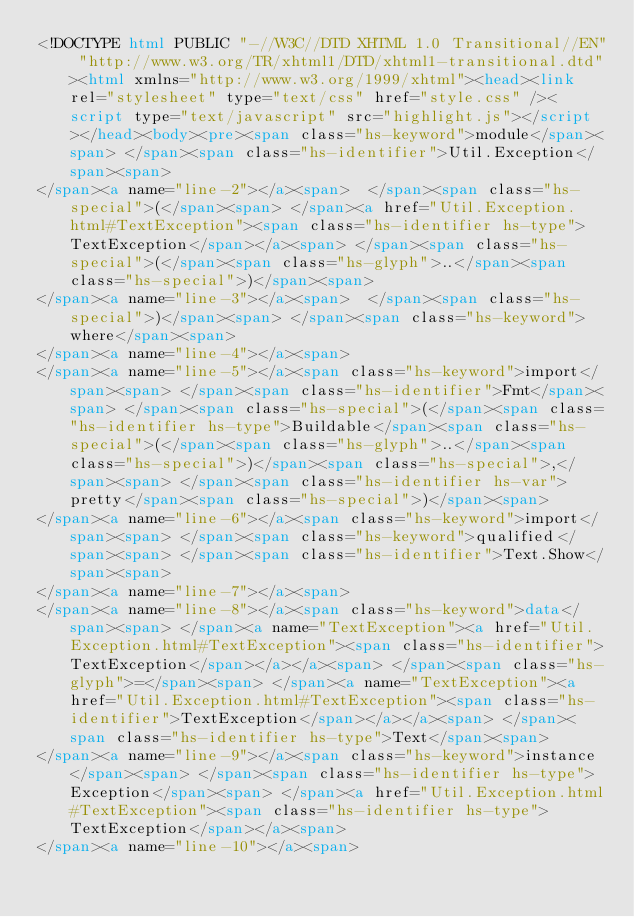<code> <loc_0><loc_0><loc_500><loc_500><_HTML_><!DOCTYPE html PUBLIC "-//W3C//DTD XHTML 1.0 Transitional//EN" "http://www.w3.org/TR/xhtml1/DTD/xhtml1-transitional.dtd"><html xmlns="http://www.w3.org/1999/xhtml"><head><link rel="stylesheet" type="text/css" href="style.css" /><script type="text/javascript" src="highlight.js"></script></head><body><pre><span class="hs-keyword">module</span><span> </span><span class="hs-identifier">Util.Exception</span><span>
</span><a name="line-2"></a><span>  </span><span class="hs-special">(</span><span> </span><a href="Util.Exception.html#TextException"><span class="hs-identifier hs-type">TextException</span></a><span> </span><span class="hs-special">(</span><span class="hs-glyph">..</span><span class="hs-special">)</span><span>
</span><a name="line-3"></a><span>  </span><span class="hs-special">)</span><span> </span><span class="hs-keyword">where</span><span>
</span><a name="line-4"></a><span>
</span><a name="line-5"></a><span class="hs-keyword">import</span><span> </span><span class="hs-identifier">Fmt</span><span> </span><span class="hs-special">(</span><span class="hs-identifier hs-type">Buildable</span><span class="hs-special">(</span><span class="hs-glyph">..</span><span class="hs-special">)</span><span class="hs-special">,</span><span> </span><span class="hs-identifier hs-var">pretty</span><span class="hs-special">)</span><span>
</span><a name="line-6"></a><span class="hs-keyword">import</span><span> </span><span class="hs-keyword">qualified</span><span> </span><span class="hs-identifier">Text.Show</span><span>
</span><a name="line-7"></a><span>
</span><a name="line-8"></a><span class="hs-keyword">data</span><span> </span><a name="TextException"><a href="Util.Exception.html#TextException"><span class="hs-identifier">TextException</span></a></a><span> </span><span class="hs-glyph">=</span><span> </span><a name="TextException"><a href="Util.Exception.html#TextException"><span class="hs-identifier">TextException</span></a></a><span> </span><span class="hs-identifier hs-type">Text</span><span>
</span><a name="line-9"></a><span class="hs-keyword">instance</span><span> </span><span class="hs-identifier hs-type">Exception</span><span> </span><a href="Util.Exception.html#TextException"><span class="hs-identifier hs-type">TextException</span></a><span>
</span><a name="line-10"></a><span></code> 